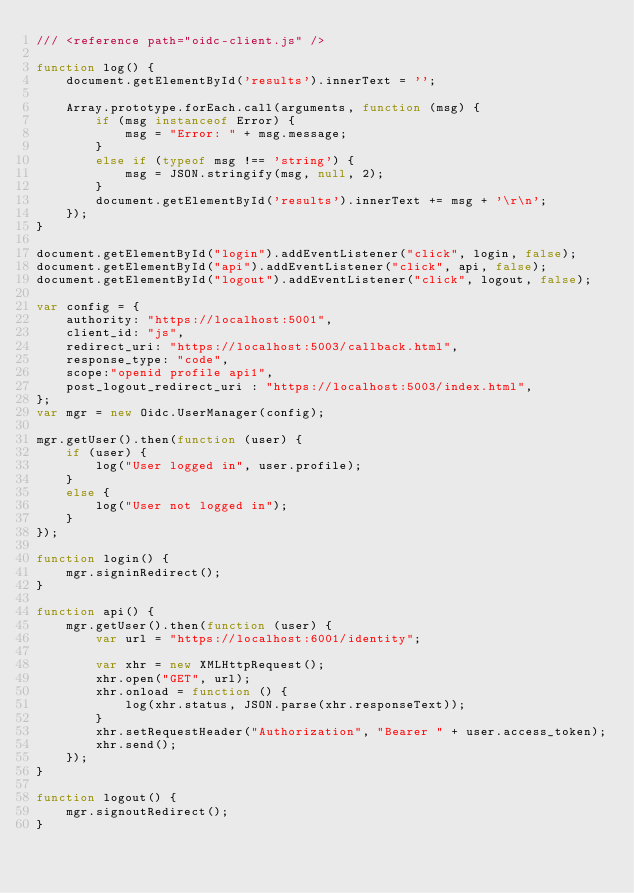<code> <loc_0><loc_0><loc_500><loc_500><_JavaScript_>/// <reference path="oidc-client.js" />

function log() {
    document.getElementById('results').innerText = '';

    Array.prototype.forEach.call(arguments, function (msg) {
        if (msg instanceof Error) {
            msg = "Error: " + msg.message;
        }
        else if (typeof msg !== 'string') {
            msg = JSON.stringify(msg, null, 2);
        }
        document.getElementById('results').innerText += msg + '\r\n';
    });
}

document.getElementById("login").addEventListener("click", login, false);
document.getElementById("api").addEventListener("click", api, false);
document.getElementById("logout").addEventListener("click", logout, false);

var config = {
    authority: "https://localhost:5001",
    client_id: "js",
    redirect_uri: "https://localhost:5003/callback.html",
    response_type: "code",
    scope:"openid profile api1",
    post_logout_redirect_uri : "https://localhost:5003/index.html",
};
var mgr = new Oidc.UserManager(config);

mgr.getUser().then(function (user) {
    if (user) {
        log("User logged in", user.profile);
    }
    else {
        log("User not logged in");
    }
});

function login() {
    mgr.signinRedirect();
}

function api() {
    mgr.getUser().then(function (user) {
        var url = "https://localhost:6001/identity";

        var xhr = new XMLHttpRequest();
        xhr.open("GET", url);
        xhr.onload = function () {
            log(xhr.status, JSON.parse(xhr.responseText));
        }
        xhr.setRequestHeader("Authorization", "Bearer " + user.access_token);
        xhr.send();
    });
}

function logout() {
    mgr.signoutRedirect();
}</code> 